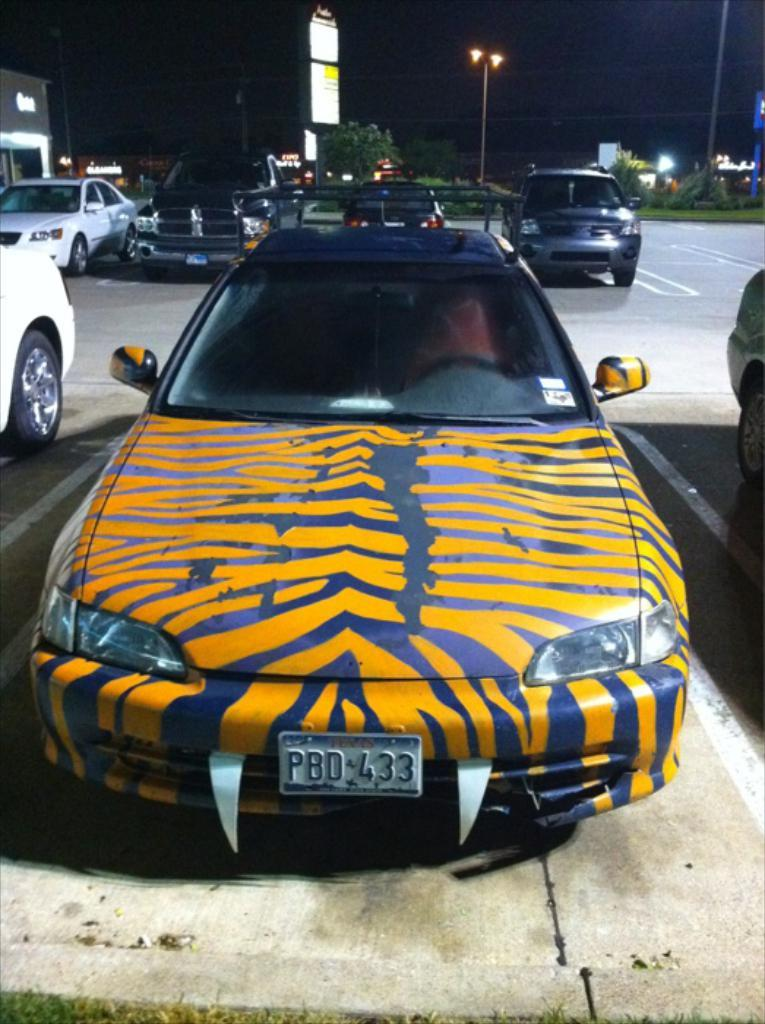<image>
Summarize the visual content of the image. A car with the license PBD 433 has fake fangs on the front of it. 